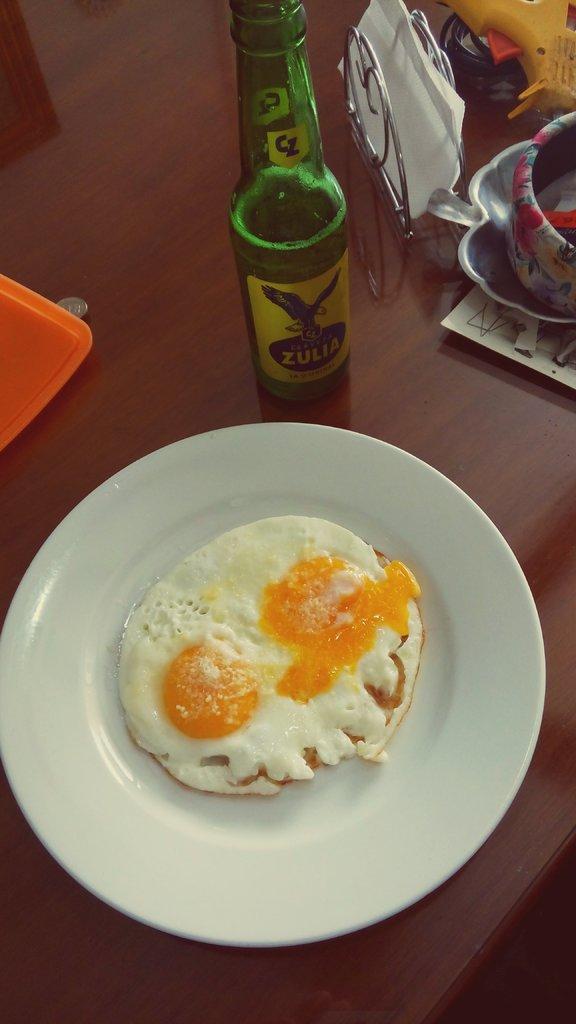Could you give a brief overview of what you see in this image? In this image we can see an egg omelet in the plate, beside there is a wine bottle, tissues, and some objects on the wooden table. 